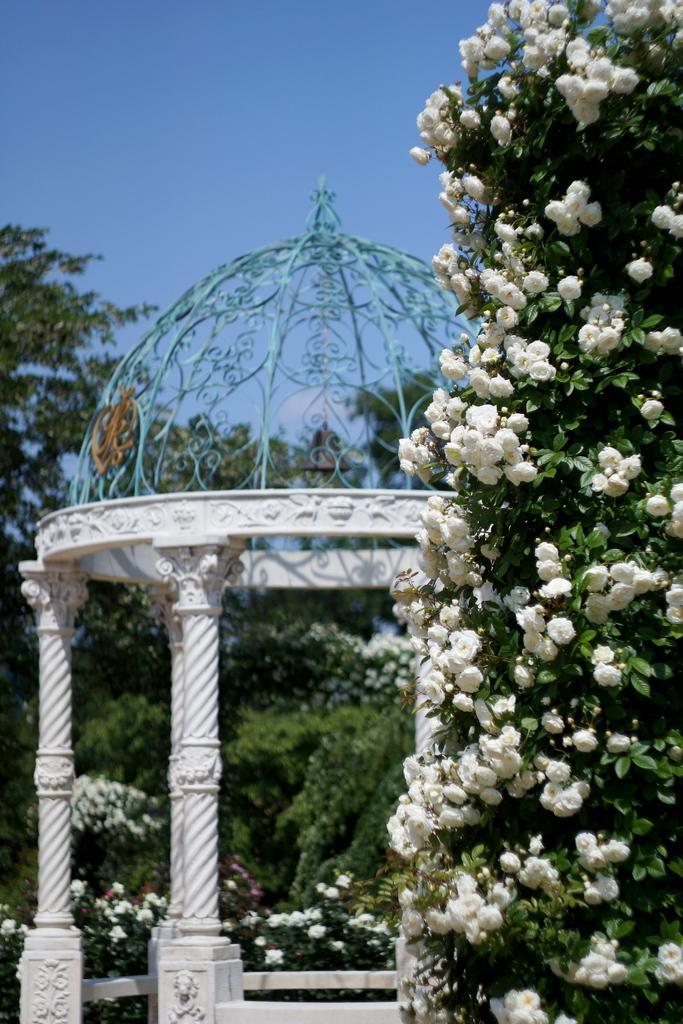How would you summarize this image in a sentence or two? This image is taken outdoors. At the top of the image there is a sky. In the background there are many trees and plants. On the right side of the image there is a creeper with many white colored flowers. In the middle of the image there is a tent. 